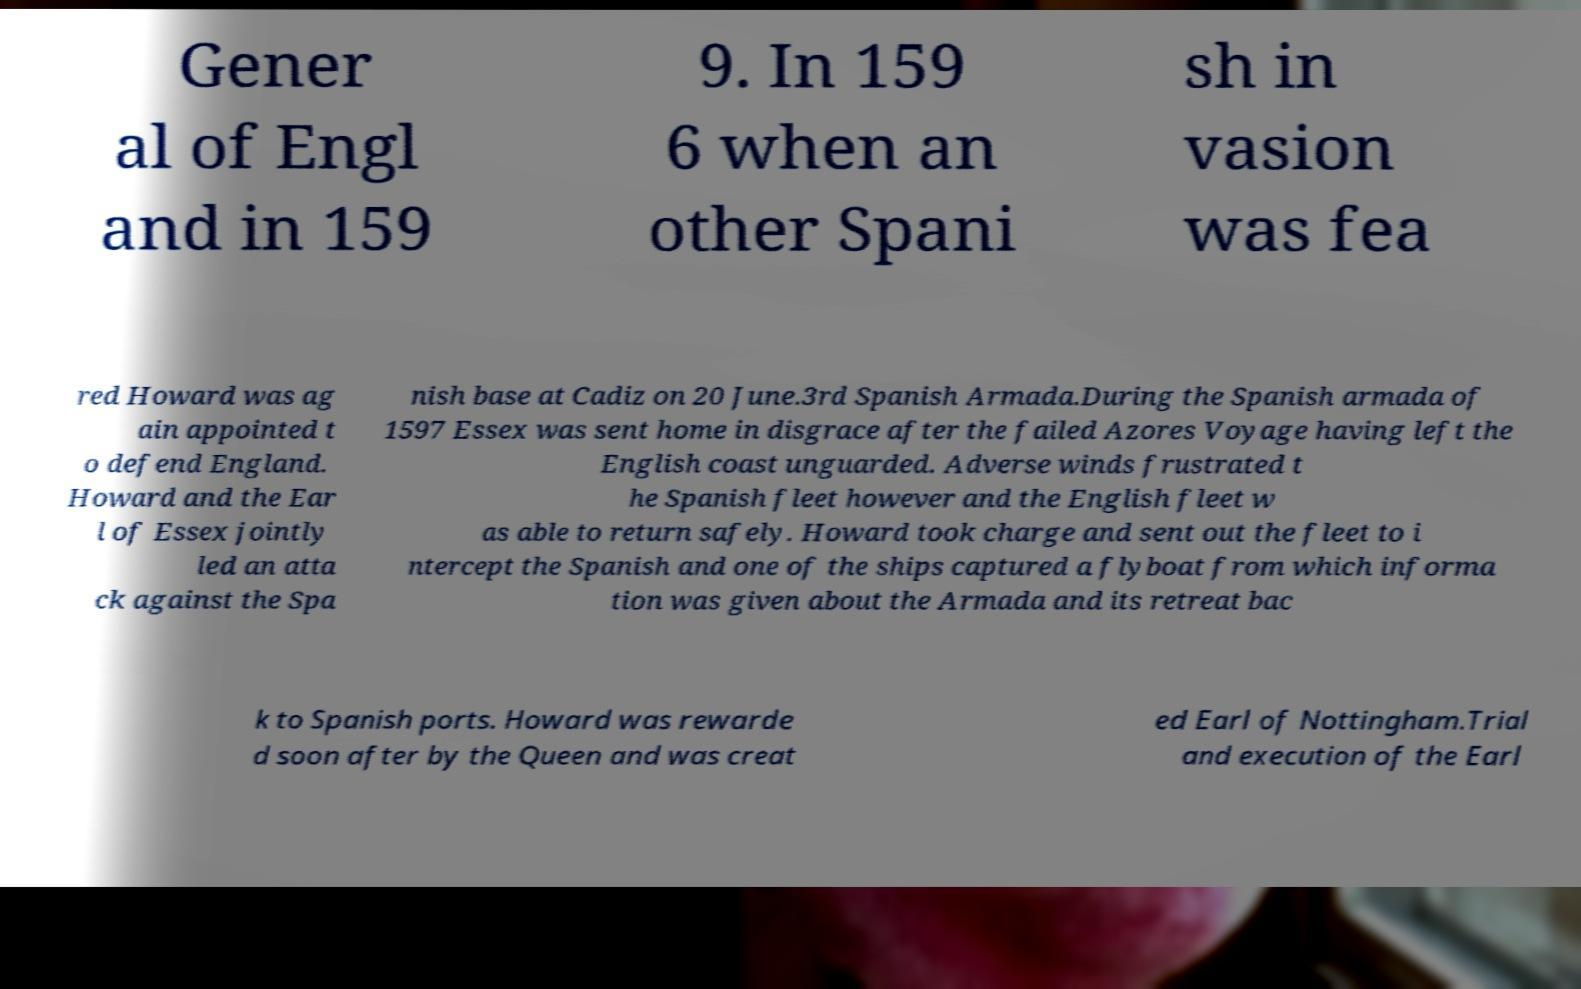What messages or text are displayed in this image? I need them in a readable, typed format. Gener al of Engl and in 159 9. In 159 6 when an other Spani sh in vasion was fea red Howard was ag ain appointed t o defend England. Howard and the Ear l of Essex jointly led an atta ck against the Spa nish base at Cadiz on 20 June.3rd Spanish Armada.During the Spanish armada of 1597 Essex was sent home in disgrace after the failed Azores Voyage having left the English coast unguarded. Adverse winds frustrated t he Spanish fleet however and the English fleet w as able to return safely. Howard took charge and sent out the fleet to i ntercept the Spanish and one of the ships captured a flyboat from which informa tion was given about the Armada and its retreat bac k to Spanish ports. Howard was rewarde d soon after by the Queen and was creat ed Earl of Nottingham.Trial and execution of the Earl 